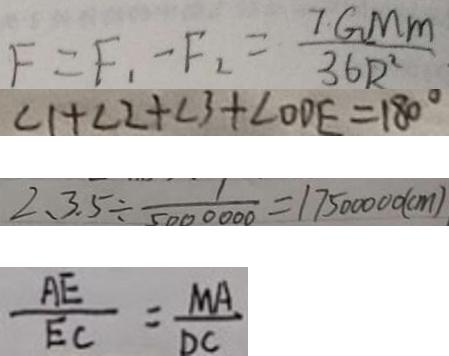Convert formula to latex. <formula><loc_0><loc_0><loc_500><loc_500>F = F _ { 1 } - F _ { 2 } = \frac { 7 G M m } { 3 6 R ^ { 2 } } 
 \angle 1 + \angle 2 + \angle 3 + \angle O D E = 1 8 0 ^ { \circ } 
 2 、 3 . 5 \div \frac { 1 } { 5 0 0 0 0 0 0 } = 1 7 5 0 0 0 0 0 ( c m ) 
 \frac { A E } { E C } = \frac { M A } { D C }</formula> 